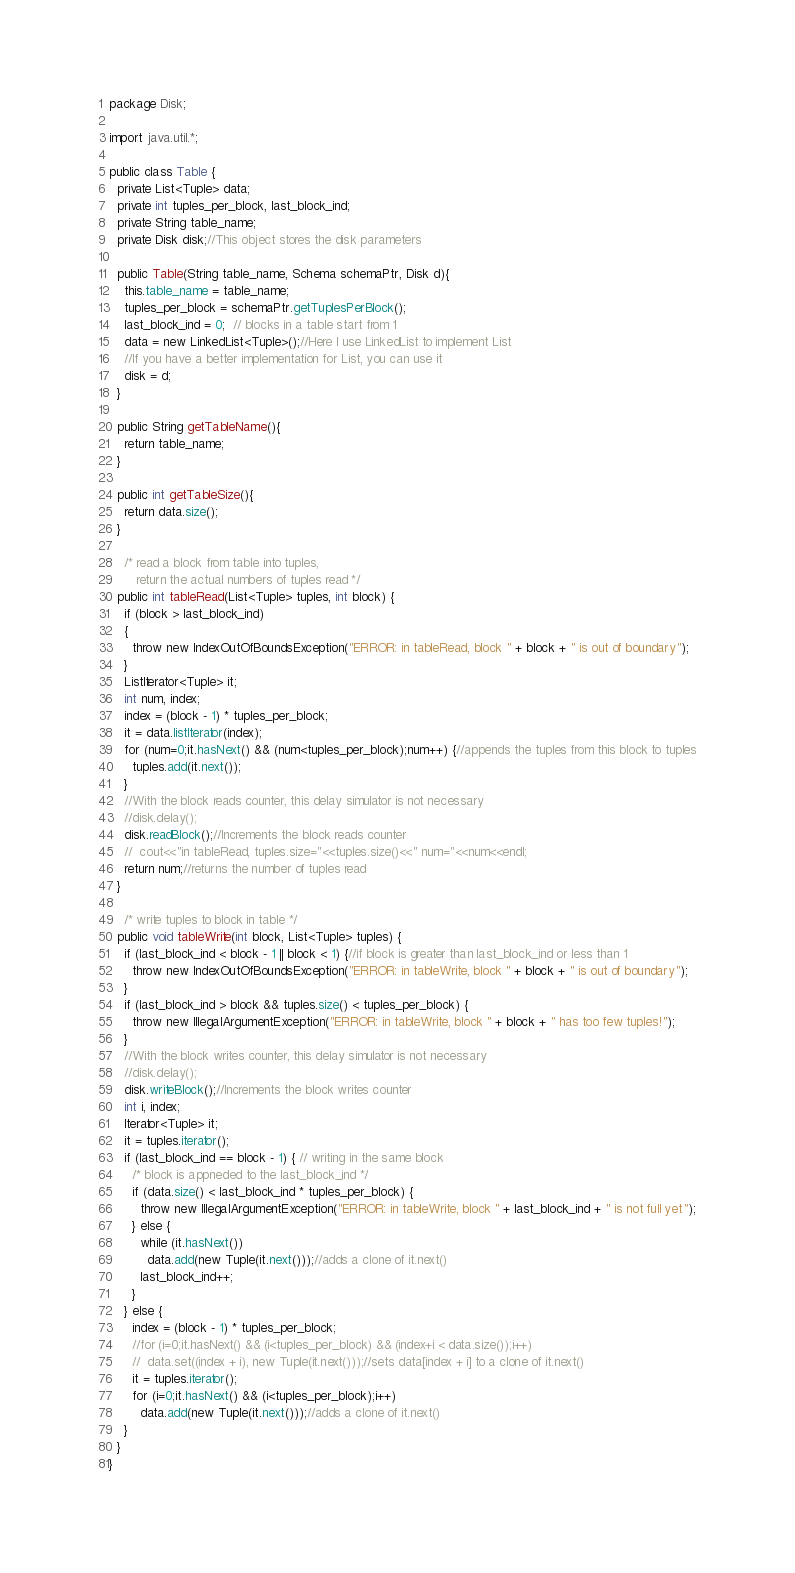Convert code to text. <code><loc_0><loc_0><loc_500><loc_500><_Java_>package Disk;

import java.util.*;

public class Table {
  private List<Tuple> data;
  private int tuples_per_block, last_block_ind;
  private String table_name;
  private Disk disk;//This object stores the disk parameters

  public Table(String table_name, Schema schemaPtr, Disk d){
    this.table_name = table_name;
    tuples_per_block = schemaPtr.getTuplesPerBlock();
    last_block_ind = 0;  // blocks in a table start from 1
    data = new LinkedList<Tuple>();//Here I use LinkedList to implement List
    //If you have a better implementation for List, you can use it
    disk = d;
  }

  public String getTableName(){
    return table_name;
  }

  public int getTableSize(){
    return data.size();
  }

	/* read a block from table into tuples, 
	   return the actual numbers of tuples read */
  public int tableRead(List<Tuple> tuples, int block) {
    if (block > last_block_ind) 
    {
      throw new IndexOutOfBoundsException("ERROR: in tableRead, block " + block + " is out of boundary");
    }
    ListIterator<Tuple> it;
    int num, index;
    index = (block - 1) * tuples_per_block;
    it = data.listIterator(index);
    for (num=0;it.hasNext() && (num<tuples_per_block);num++) {//appends the tuples from this block to tuples
      tuples.add(it.next());
    }
    //With the block reads counter, this delay simulator is not necessary
    //disk.delay();
    disk.readBlock();//Increments the block reads counter
    //  cout<<"in tableRead, tuples.size="<<tuples.size()<<" num="<<num<<endl;
    return num;//returns the number of tuples read
  }

	/* write tuples to block in table */
  public void tableWrite(int block, List<Tuple> tuples) {
    if (last_block_ind < block - 1 || block < 1) {//if block is greater than last_block_ind or less than 1
      throw new IndexOutOfBoundsException("ERROR: in tableWrite, block " + block + " is out of boundary");
    }
    if (last_block_ind > block && tuples.size() < tuples_per_block) {
      throw new IllegalArgumentException("ERROR: in tableWrite, block " + block + " has too few tuples!");
    }
    //With the block writes counter, this delay simulator is not necessary
    //disk.delay();
    disk.writeBlock();//Increments the block writes counter
    int i, index;
    Iterator<Tuple> it;
    it = tuples.iterator();
    if (last_block_ind == block - 1) { // writing in the same block
      /* block is appneded to the last_block_ind */
      if (data.size() < last_block_ind * tuples_per_block) {
        throw new IllegalArgumentException("ERROR: in tableWrite, block " + last_block_ind + " is not full yet");
      } else {
        while (it.hasNext())
          data.add(new Tuple(it.next()));//adds a clone of it.next()
        last_block_ind++;
      }
    } else {
      index = (block - 1) * tuples_per_block;
      //for (i=0;it.hasNext() && (i<tuples_per_block) && (index+i < data.size());i++)
      //  data.set((index + i), new Tuple(it.next()));//sets data[index + i] to a clone of it.next()
      it = tuples.iterator();
      for (i=0;it.hasNext() && (i<tuples_per_block);i++)
        data.add(new Tuple(it.next()));//adds a clone of it.next()
    }
  }
}
</code> 